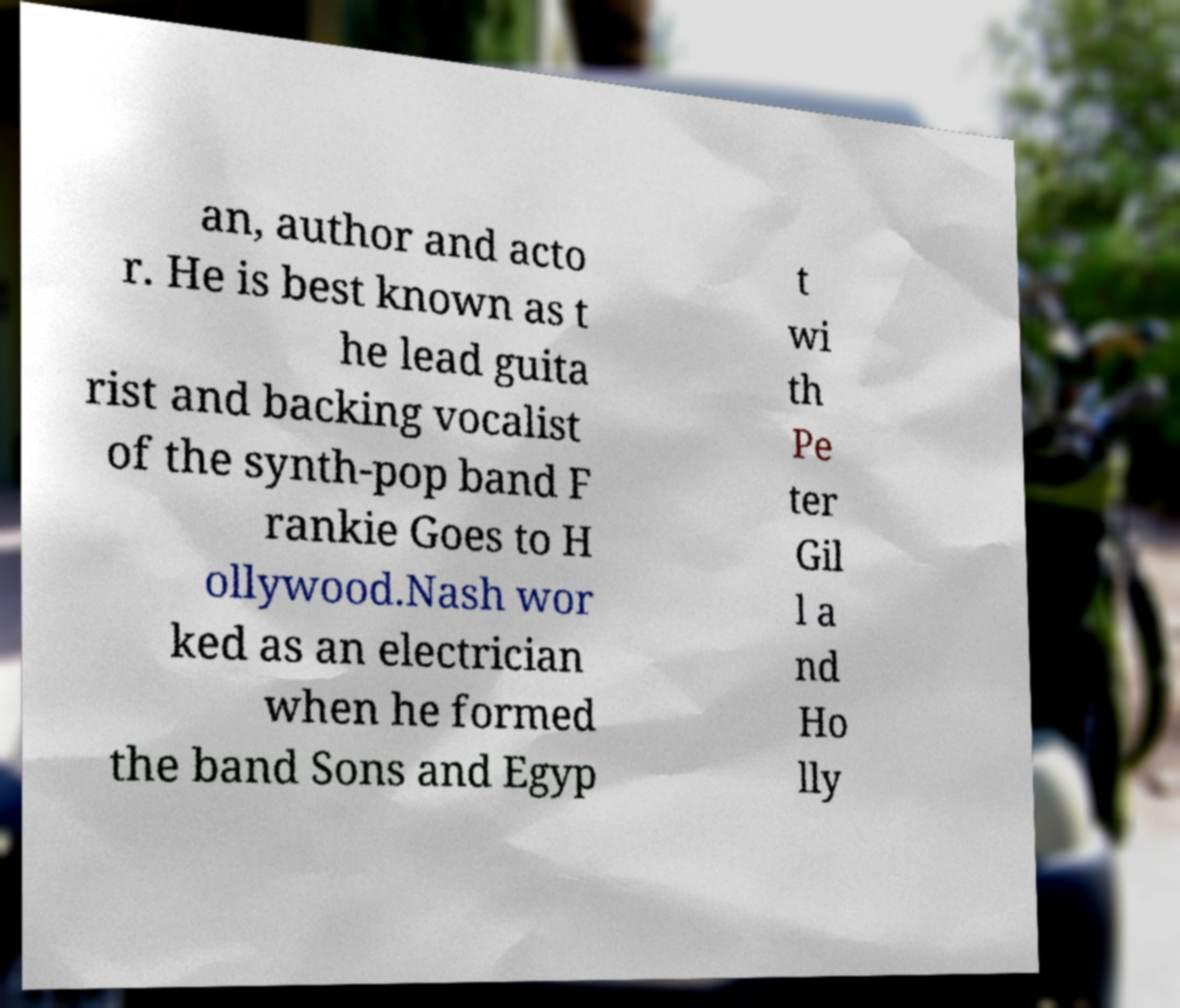Can you read and provide the text displayed in the image?This photo seems to have some interesting text. Can you extract and type it out for me? an, author and acto r. He is best known as t he lead guita rist and backing vocalist of the synth-pop band F rankie Goes to H ollywood.Nash wor ked as an electrician when he formed the band Sons and Egyp t wi th Pe ter Gil l a nd Ho lly 